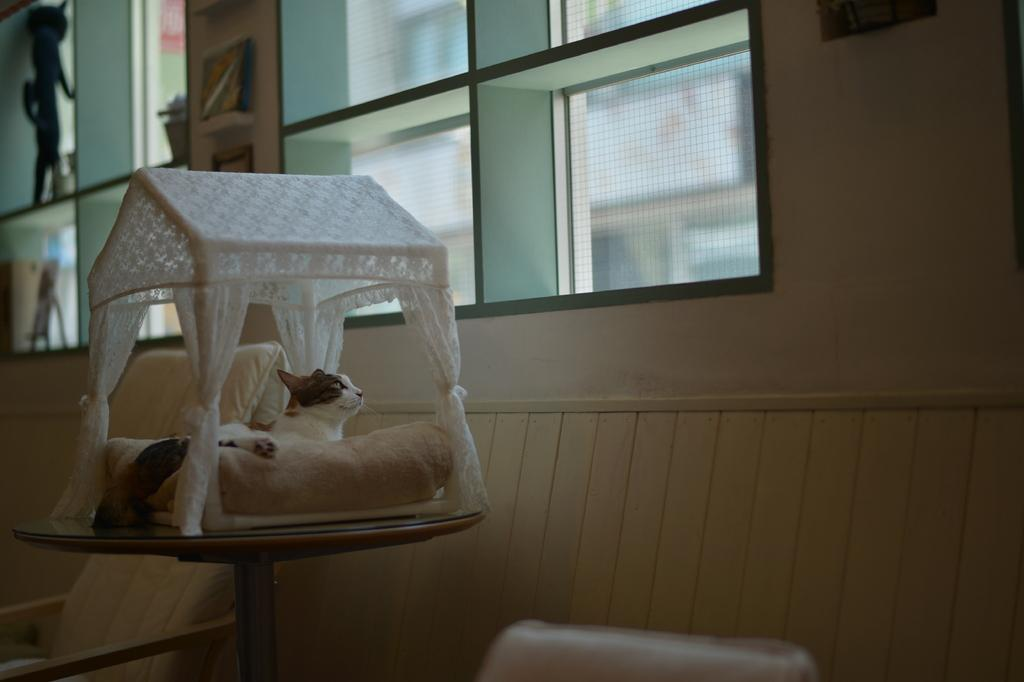What type of animal is in the image? There is a cat in the image. Where is the cat located? The cat is in a small house. What can be seen in the background of the image? There is a wall and a chair in the background of the image. What type of foot is visible in the image? There is no foot visible in the image; it only features a cat in a small house with a wall and a chair in the background. 